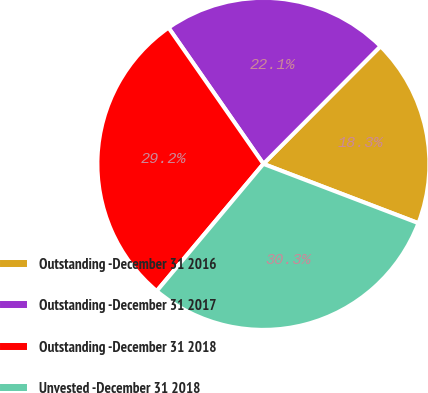Convert chart to OTSL. <chart><loc_0><loc_0><loc_500><loc_500><pie_chart><fcel>Outstanding -December 31 2016<fcel>Outstanding -December 31 2017<fcel>Outstanding -December 31 2018<fcel>Unvested -December 31 2018<nl><fcel>18.35%<fcel>22.15%<fcel>29.21%<fcel>30.3%<nl></chart> 